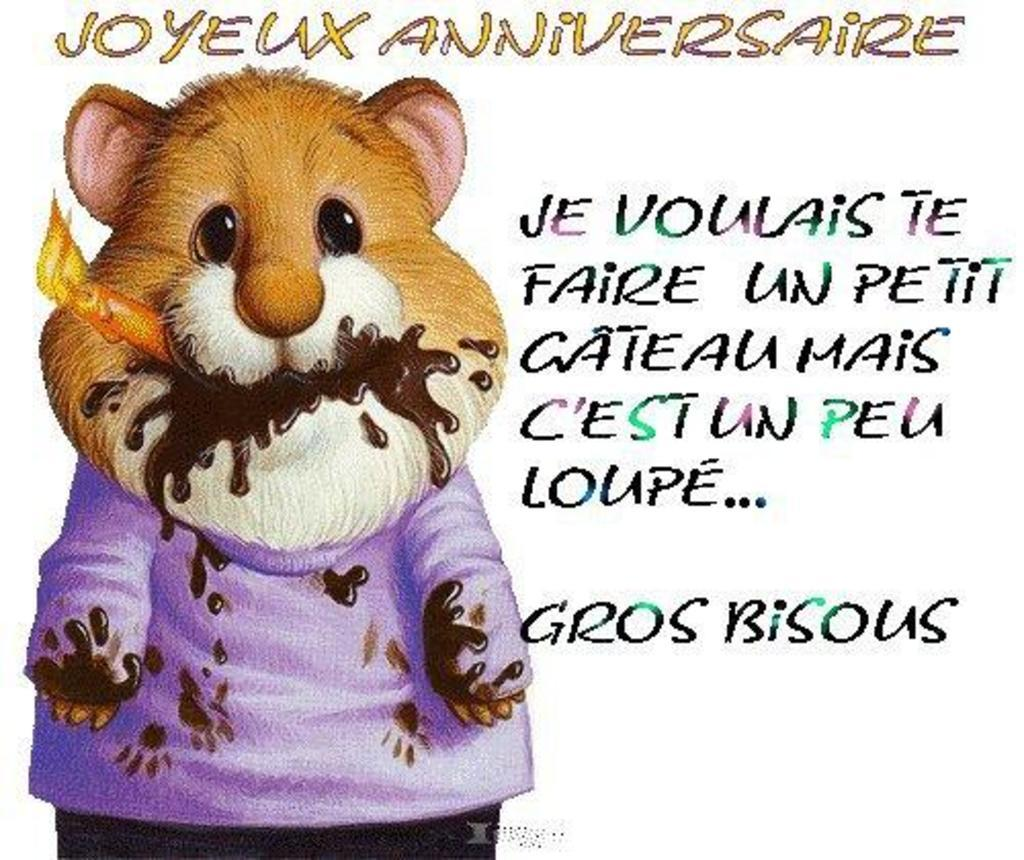What type of character is depicted in the image? There is a cartoon figure in the image. What can be found beside the cartoon figure? There is text written beside the cartoon figure. What type of bird is flying above the cartoon figure in the image? There is no bird present in the image; it only features a cartoon figure and text beside it. 